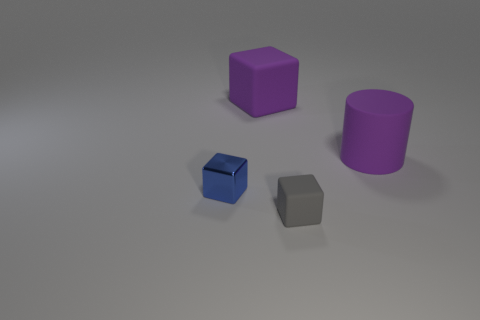Add 1 large cylinders. How many objects exist? 5 Subtract all blocks. How many objects are left? 1 Subtract all rubber blocks. Subtract all small metallic things. How many objects are left? 1 Add 1 purple cubes. How many purple cubes are left? 2 Add 2 purple rubber things. How many purple rubber things exist? 4 Subtract 0 blue cylinders. How many objects are left? 4 